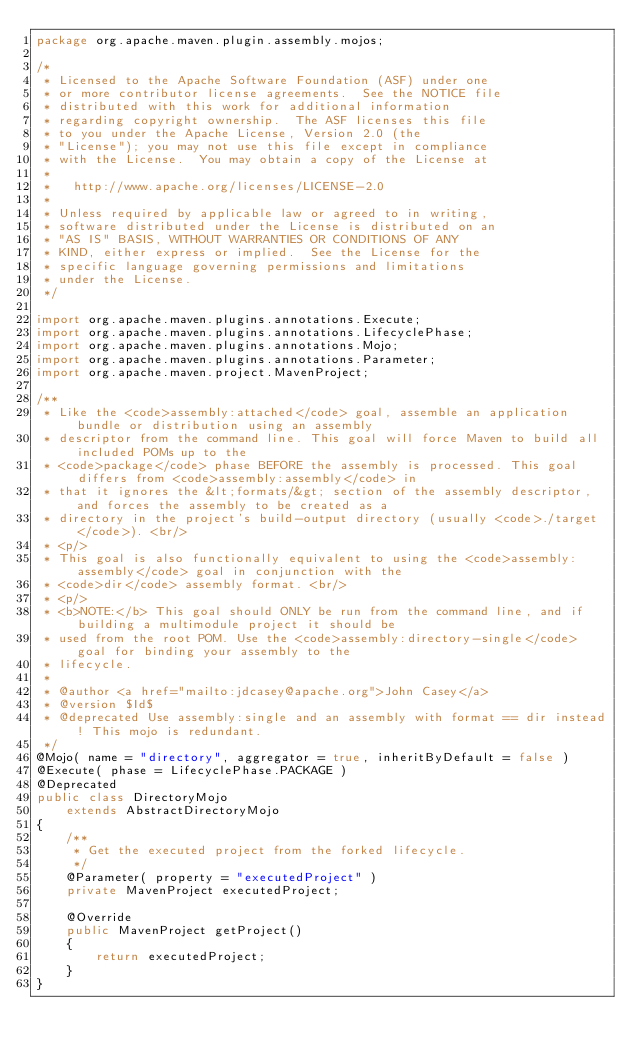Convert code to text. <code><loc_0><loc_0><loc_500><loc_500><_Java_>package org.apache.maven.plugin.assembly.mojos;

/*
 * Licensed to the Apache Software Foundation (ASF) under one
 * or more contributor license agreements.  See the NOTICE file
 * distributed with this work for additional information
 * regarding copyright ownership.  The ASF licenses this file
 * to you under the Apache License, Version 2.0 (the
 * "License"); you may not use this file except in compliance
 * with the License.  You may obtain a copy of the License at
 *
 *   http://www.apache.org/licenses/LICENSE-2.0
 *
 * Unless required by applicable law or agreed to in writing,
 * software distributed under the License is distributed on an
 * "AS IS" BASIS, WITHOUT WARRANTIES OR CONDITIONS OF ANY
 * KIND, either express or implied.  See the License for the
 * specific language governing permissions and limitations
 * under the License.
 */

import org.apache.maven.plugins.annotations.Execute;
import org.apache.maven.plugins.annotations.LifecyclePhase;
import org.apache.maven.plugins.annotations.Mojo;
import org.apache.maven.plugins.annotations.Parameter;
import org.apache.maven.project.MavenProject;

/**
 * Like the <code>assembly:attached</code> goal, assemble an application bundle or distribution using an assembly
 * descriptor from the command line. This goal will force Maven to build all included POMs up to the
 * <code>package</code> phase BEFORE the assembly is processed. This goal differs from <code>assembly:assembly</code> in
 * that it ignores the &lt;formats/&gt; section of the assembly descriptor, and forces the assembly to be created as a
 * directory in the project's build-output directory (usually <code>./target</code>). <br/>
 * <p/>
 * This goal is also functionally equivalent to using the <code>assembly:assembly</code> goal in conjunction with the
 * <code>dir</code> assembly format. <br/>
 * <p/>
 * <b>NOTE:</b> This goal should ONLY be run from the command line, and if building a multimodule project it should be
 * used from the root POM. Use the <code>assembly:directory-single</code> goal for binding your assembly to the
 * lifecycle.
 *
 * @author <a href="mailto:jdcasey@apache.org">John Casey</a>
 * @version $Id$
 * @deprecated Use assembly:single and an assembly with format == dir instead! This mojo is redundant.
 */
@Mojo( name = "directory", aggregator = true, inheritByDefault = false )
@Execute( phase = LifecyclePhase.PACKAGE )
@Deprecated
public class DirectoryMojo
    extends AbstractDirectoryMojo
{
    /**
     * Get the executed project from the forked lifecycle.
     */
    @Parameter( property = "executedProject" )
    private MavenProject executedProject;

    @Override
    public MavenProject getProject()
    {
        return executedProject;
    }
}
</code> 